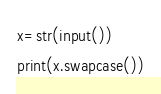Convert code to text. <code><loc_0><loc_0><loc_500><loc_500><_Python_>x=str(input())
print(x.swapcase())
</code> 